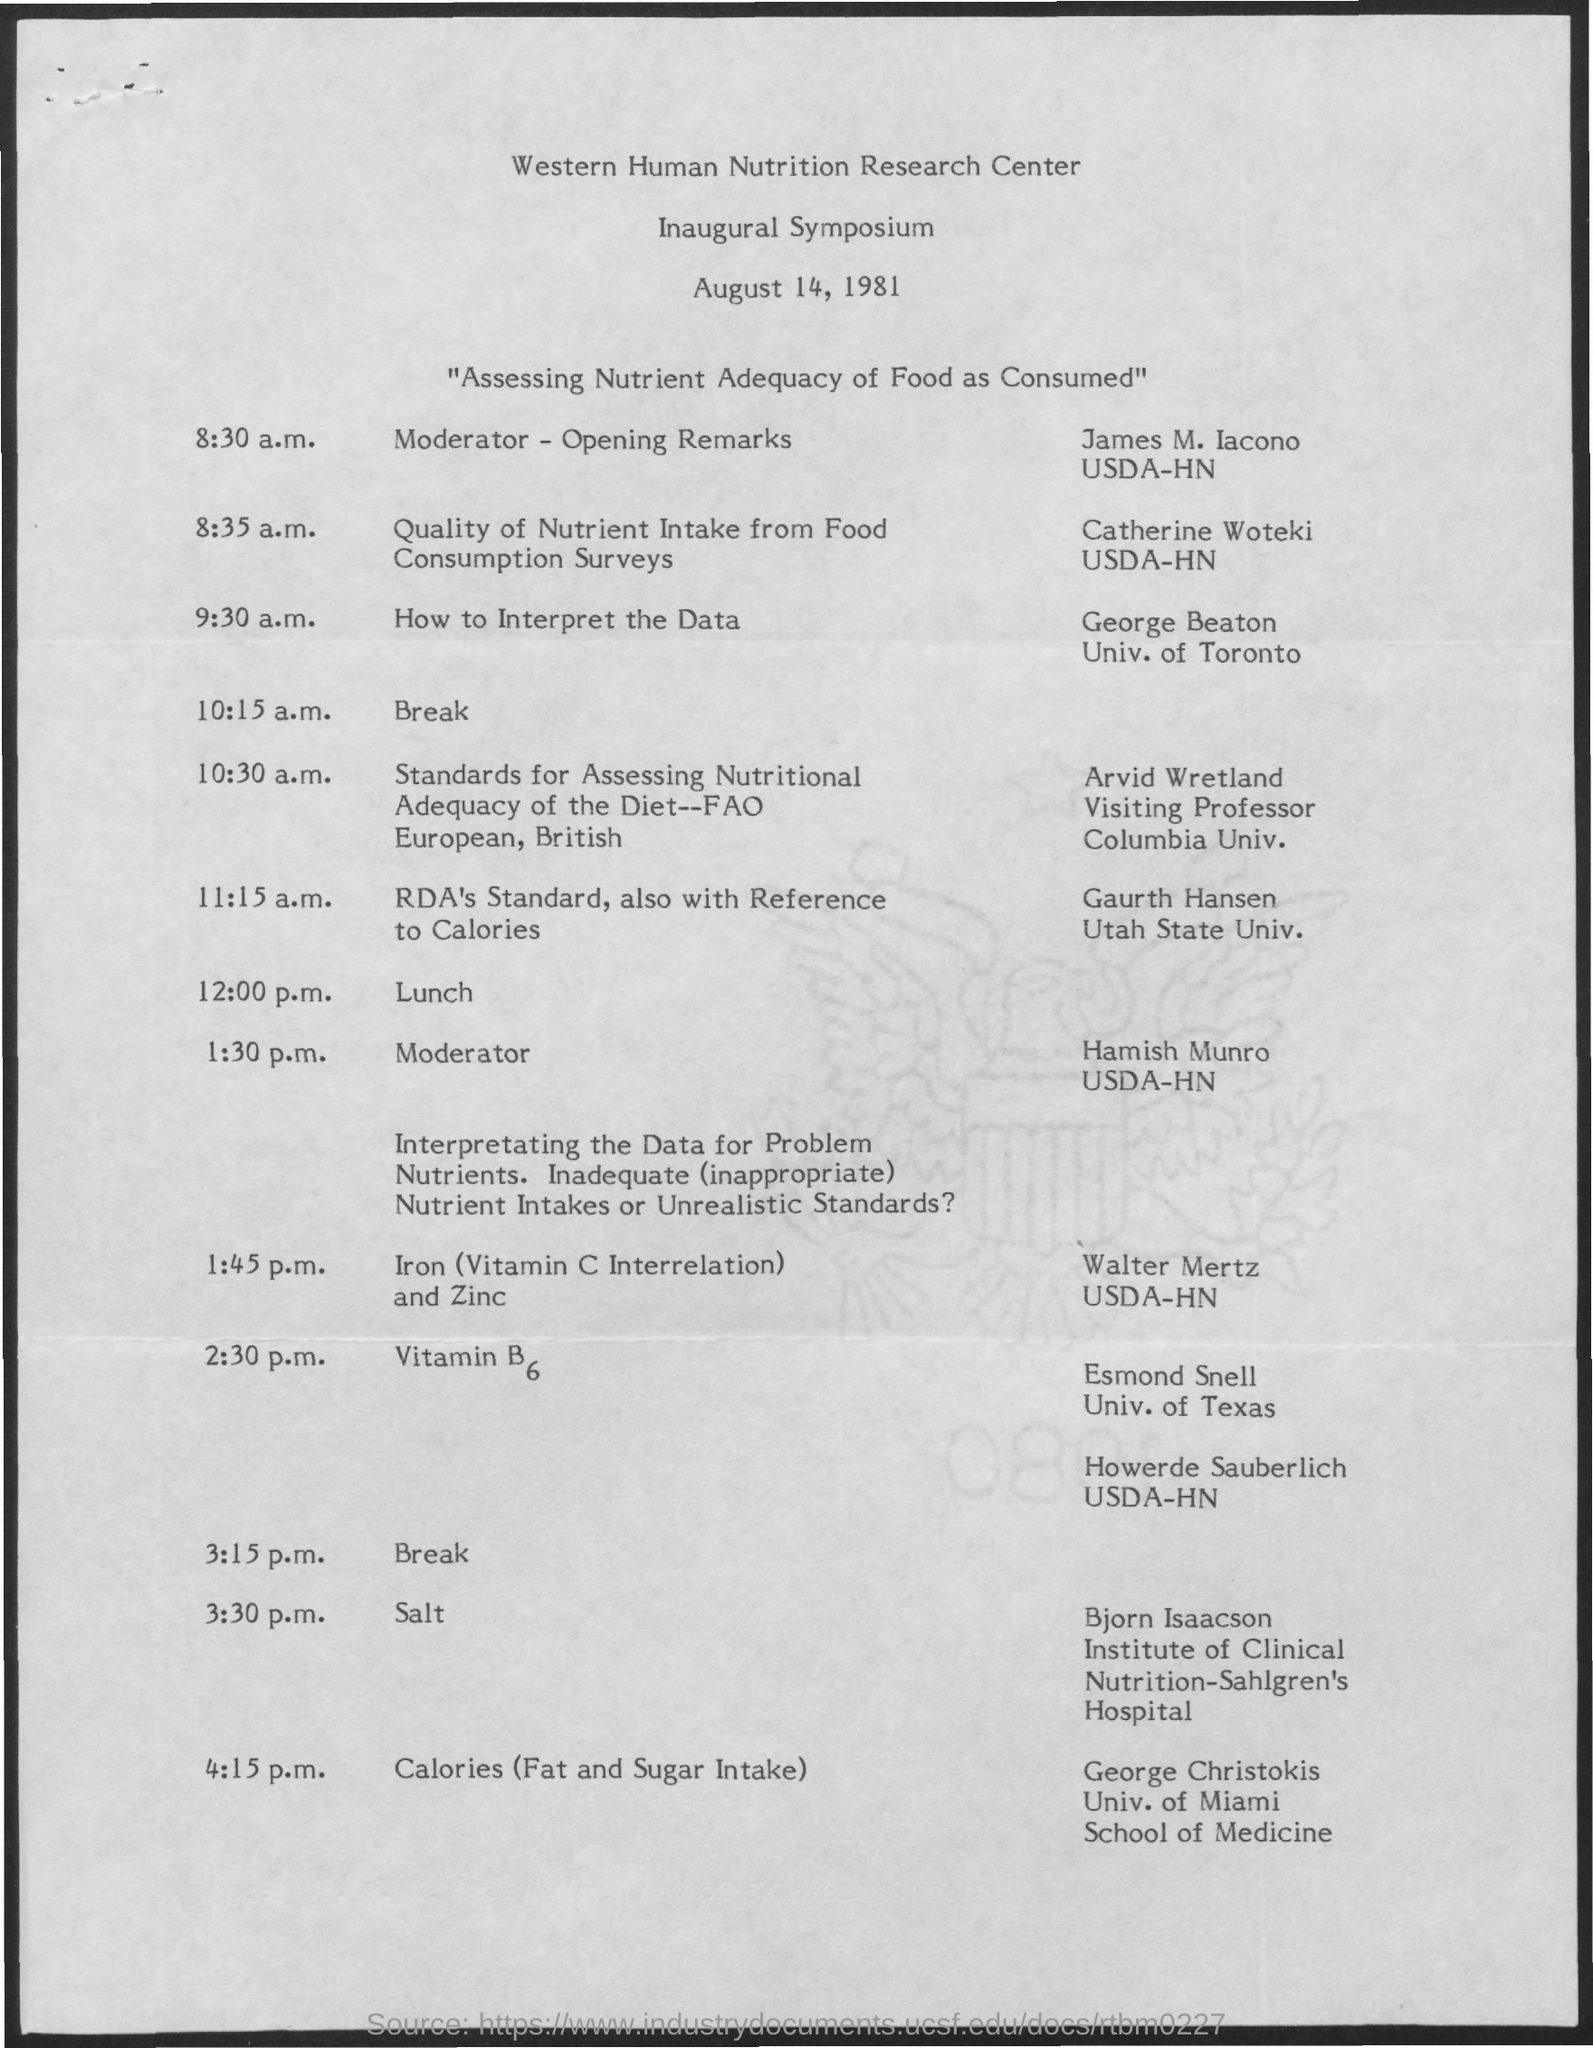When is the Inaugural Symposium?
Your answer should be very brief. August 14, 1981. When is the Opening Remarks?
Keep it short and to the point. 8:30 a.m. When is the Lunch?
Make the answer very short. 12:00 p.m. 